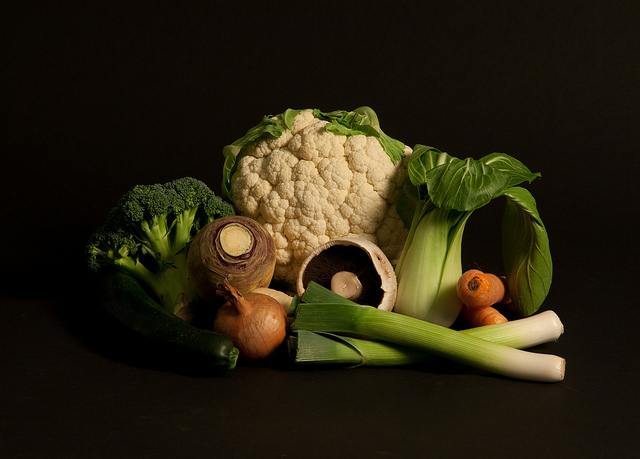What are some health benefits associated with these vegetables? These vegetables are packed with nutrients and health benefits. Broccoli contains high levels of vitamin C and K, and it has anti-inflammatory properties. Cauliflower is also rich in vitamins C and K and has compounds that may help to prevent cancer. Leeks are good sources of dietary fiber and vitamin A, which is important for good vision. Onions are rich in antioxidants and have been linked to heart health benefits. Lastly, Portobello mushrooms are a good source of protein, fiber, and several B vitamins. 